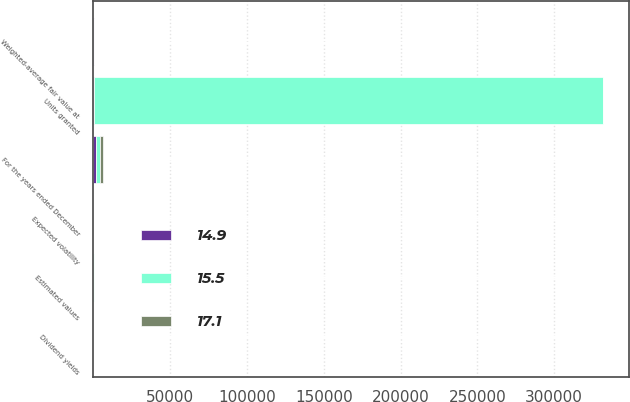Convert chart to OTSL. <chart><loc_0><loc_0><loc_500><loc_500><stacked_bar_chart><ecel><fcel>For the years ended December<fcel>Units granted<fcel>Weighted-average fair value at<fcel>Estimated values<fcel>Dividend yields<fcel>Expected volatility<nl><fcel>14.9<fcel>2015<fcel>71.085<fcel>104.68<fcel>61.22<fcel>2<fcel>14.9<nl><fcel>15.5<fcel>2014<fcel>331788<fcel>115.57<fcel>80.95<fcel>1.8<fcel>15.5<nl><fcel>17.1<fcel>2013<fcel>71.085<fcel>88.49<fcel>55.49<fcel>2<fcel>17.1<nl></chart> 